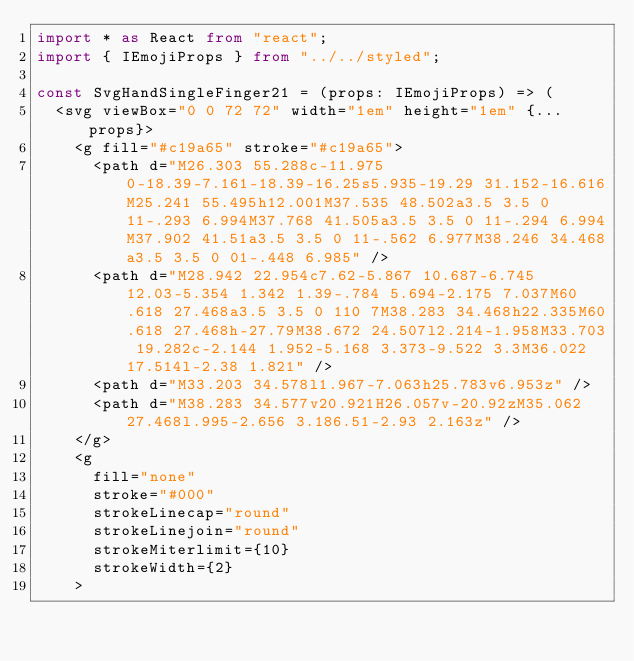Convert code to text. <code><loc_0><loc_0><loc_500><loc_500><_TypeScript_>import * as React from "react";
import { IEmojiProps } from "../../styled";

const SvgHandSingleFinger21 = (props: IEmojiProps) => (
  <svg viewBox="0 0 72 72" width="1em" height="1em" {...props}>
    <g fill="#c19a65" stroke="#c19a65">
      <path d="M26.303 55.288c-11.975 0-18.39-7.161-18.39-16.25s5.935-19.29 31.152-16.616M25.241 55.495h12.001M37.535 48.502a3.5 3.5 0 11-.293 6.994M37.768 41.505a3.5 3.5 0 11-.294 6.994M37.902 41.51a3.5 3.5 0 11-.562 6.977M38.246 34.468a3.5 3.5 0 01-.448 6.985" />
      <path d="M28.942 22.954c7.62-5.867 10.687-6.745 12.03-5.354 1.342 1.39-.784 5.694-2.175 7.037M60.618 27.468a3.5 3.5 0 110 7M38.283 34.468h22.335M60.618 27.468h-27.79M38.672 24.507l2.214-1.958M33.703 19.282c-2.144 1.952-5.168 3.373-9.522 3.3M36.022 17.514l-2.38 1.821" />
      <path d="M33.203 34.578l1.967-7.063h25.783v6.953z" />
      <path d="M38.283 34.577v20.921H26.057v-20.92zM35.062 27.468l.995-2.656 3.186.51-2.93 2.163z" />
    </g>
    <g
      fill="none"
      stroke="#000"
      strokeLinecap="round"
      strokeLinejoin="round"
      strokeMiterlimit={10}
      strokeWidth={2}
    ></code> 